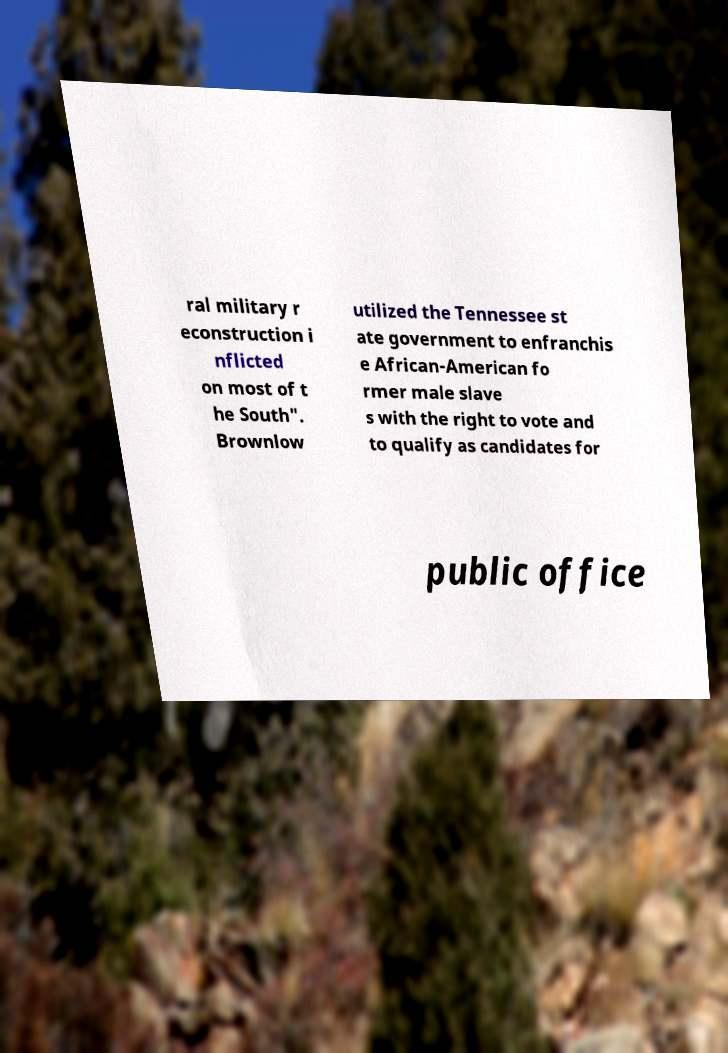Can you accurately transcribe the text from the provided image for me? ral military r econstruction i nflicted on most of t he South". Brownlow utilized the Tennessee st ate government to enfranchis e African-American fo rmer male slave s with the right to vote and to qualify as candidates for public office 